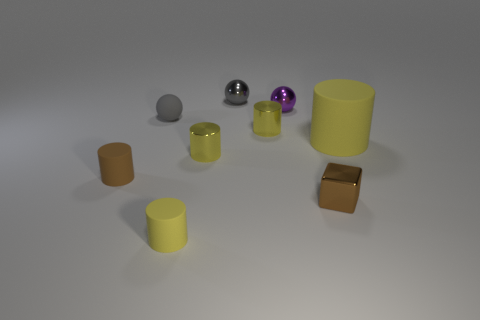There is a brown thing that is made of the same material as the purple sphere; what size is it?
Keep it short and to the point. Small. Is there a rubber ball that has the same color as the tiny metallic block?
Your answer should be compact. No. There is a tiny metal cylinder behind the big matte thing; does it have the same color as the small matte thing behind the large rubber cylinder?
Make the answer very short. No. There is a rubber object that is the same color as the metal block; what size is it?
Offer a very short reply. Small. Is there a small object that has the same material as the tiny brown cylinder?
Offer a terse response. Yes. The large matte cylinder is what color?
Your answer should be compact. Yellow. There is a matte cylinder that is in front of the tiny brown thing behind the brown block that is on the right side of the small purple shiny ball; what size is it?
Give a very brief answer. Small. What number of other things are the same shape as the large matte object?
Provide a short and direct response. 4. There is a tiny matte object that is both behind the tiny metallic cube and in front of the small gray matte thing; what color is it?
Provide a succinct answer. Brown. There is a small rubber cylinder to the left of the tiny yellow rubber object; is its color the same as the rubber sphere?
Your answer should be very brief. No. 